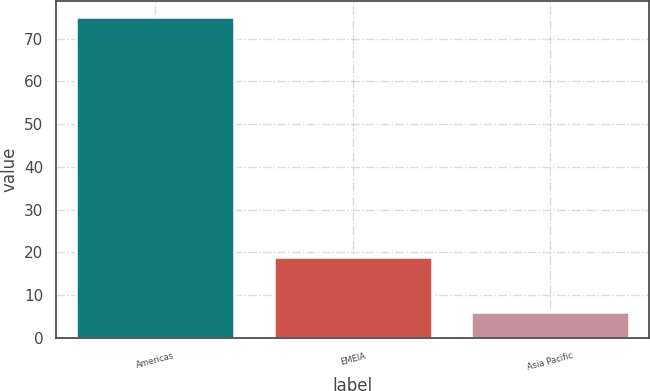<chart> <loc_0><loc_0><loc_500><loc_500><bar_chart><fcel>Americas<fcel>EMEIA<fcel>Asia Pacific<nl><fcel>75<fcel>19<fcel>6<nl></chart> 